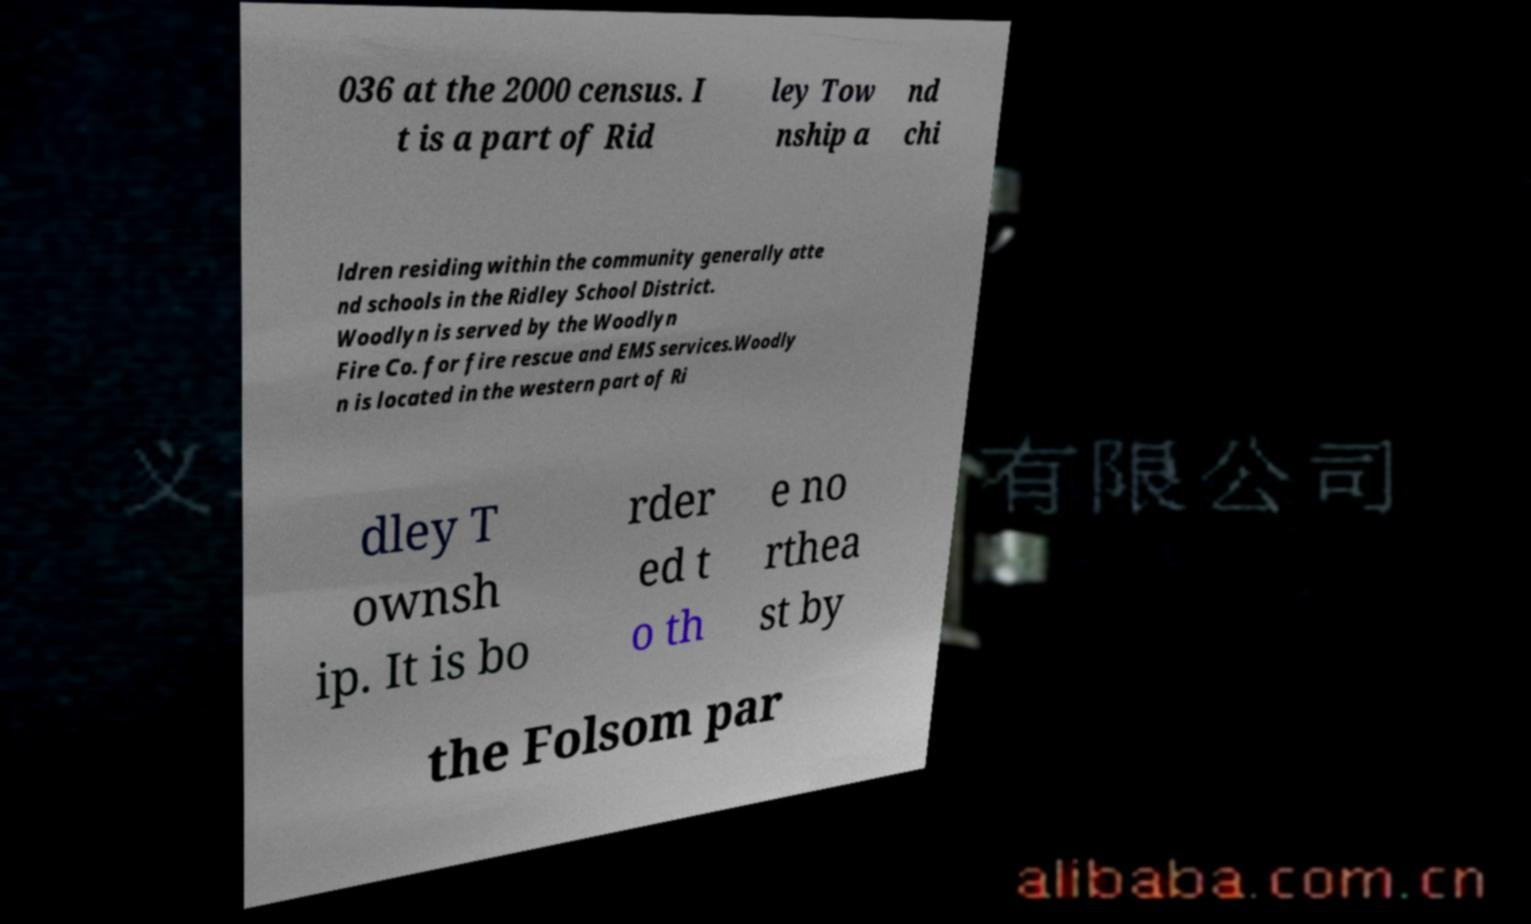I need the written content from this picture converted into text. Can you do that? 036 at the 2000 census. I t is a part of Rid ley Tow nship a nd chi ldren residing within the community generally atte nd schools in the Ridley School District. Woodlyn is served by the Woodlyn Fire Co. for fire rescue and EMS services.Woodly n is located in the western part of Ri dley T ownsh ip. It is bo rder ed t o th e no rthea st by the Folsom par 